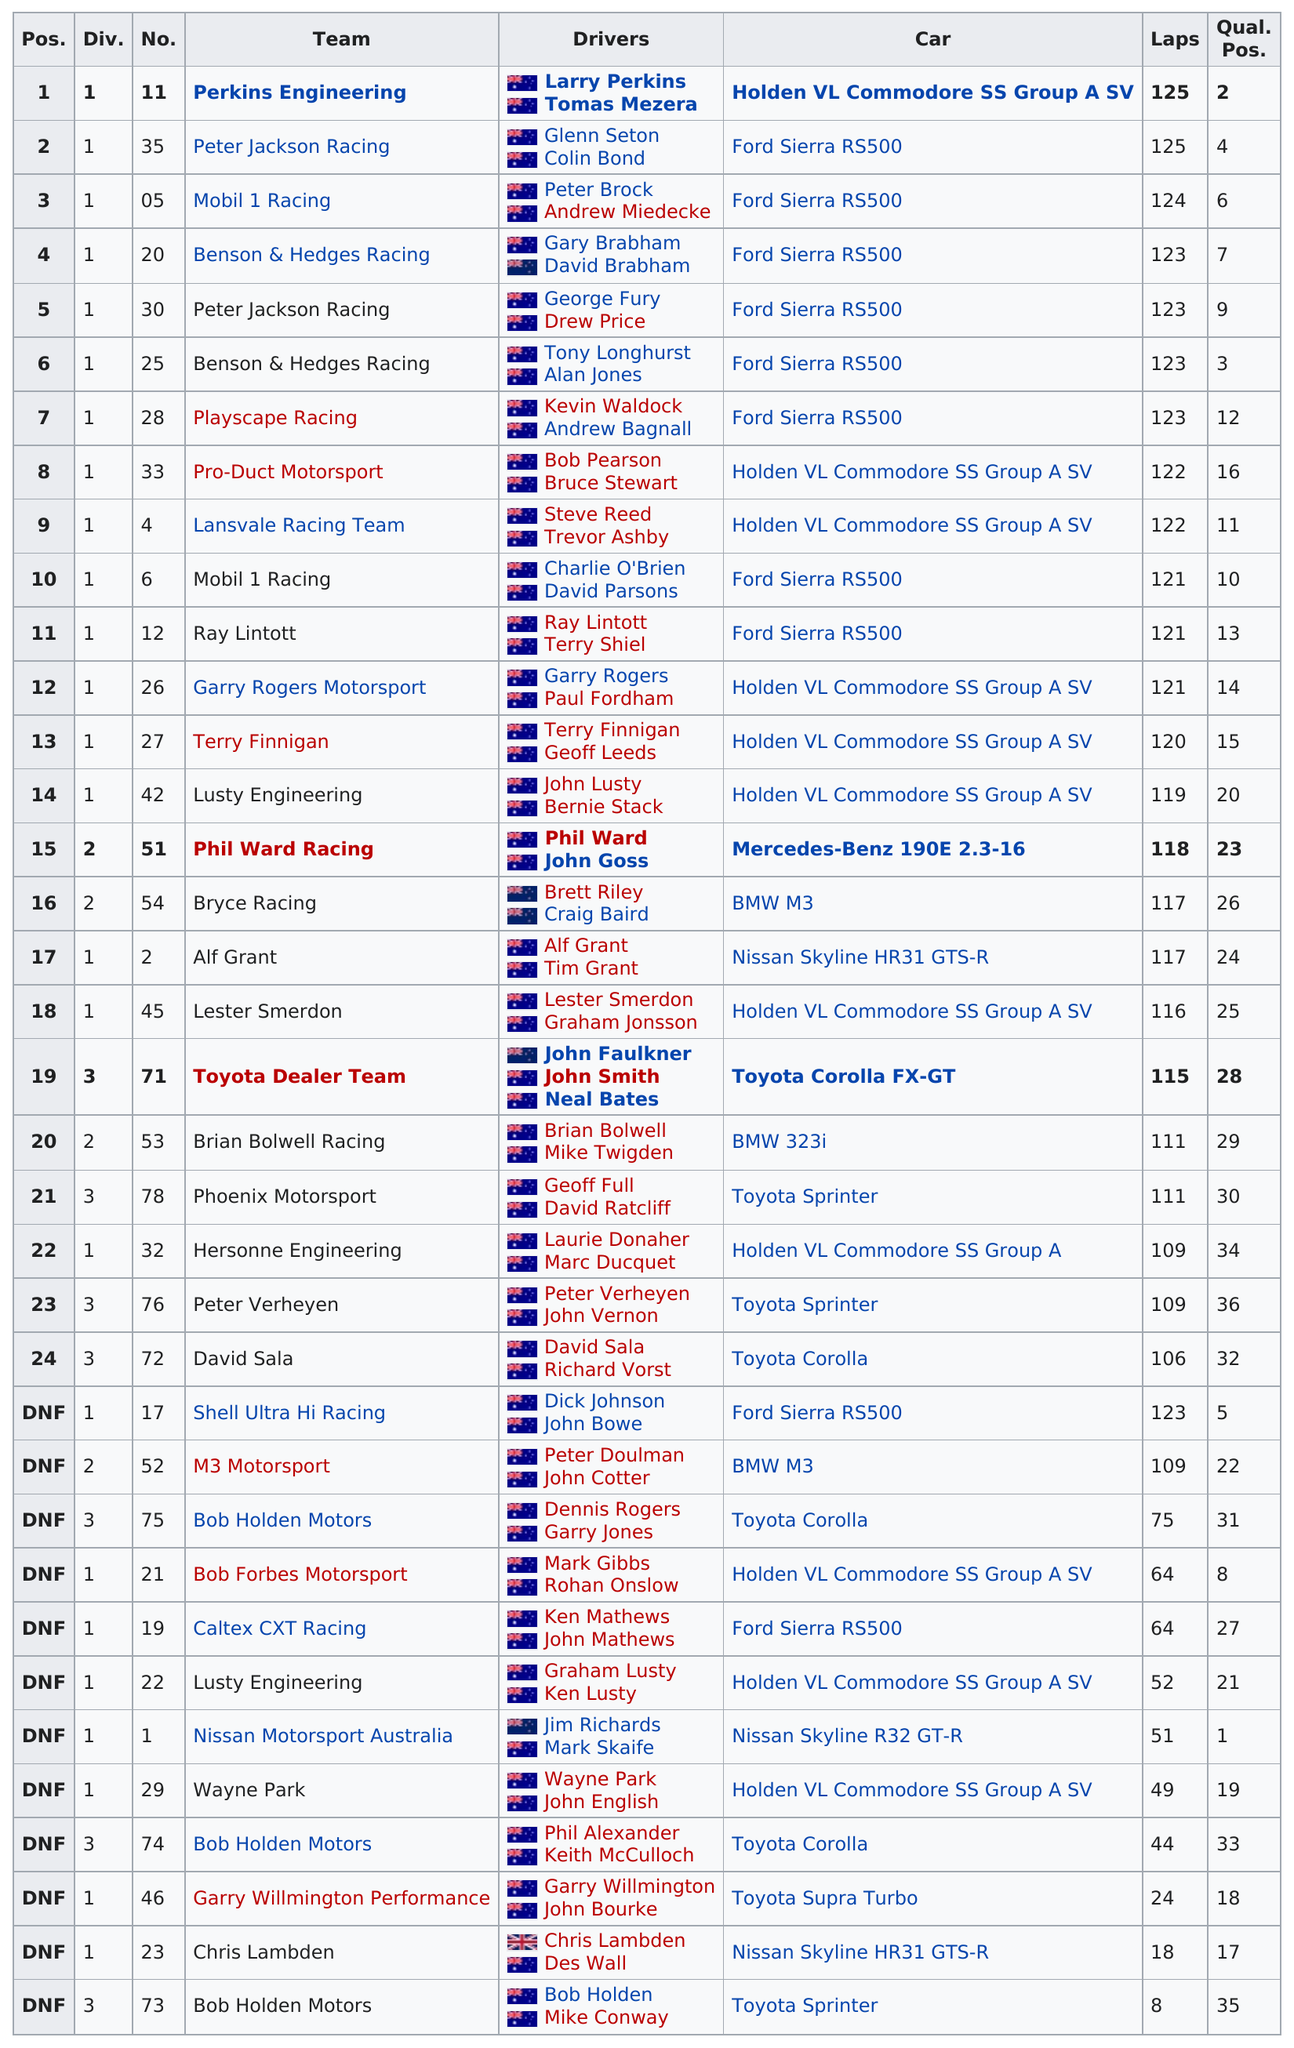Mention a couple of crucial points in this snapshot. The difference in laps between the winner, position 1, and the 24th-place finisher was 19 laps. Terry Finnigan named one team that placed before Lusty Engineering. The team that placed second after Mobil 1 Racing was Benson & Hedges Racing. Larry Perkins, along with another driver, Tomas Mezera, is under the team Perkins Engineering. Four teams are currently ranked in the top five positions. 